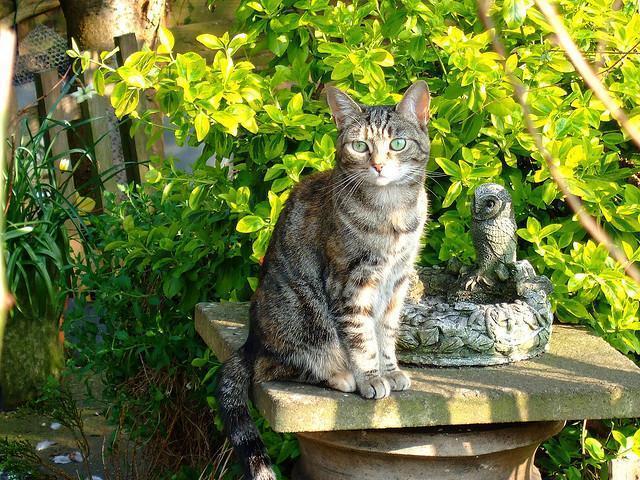How many people are entering the train?
Give a very brief answer. 0. 